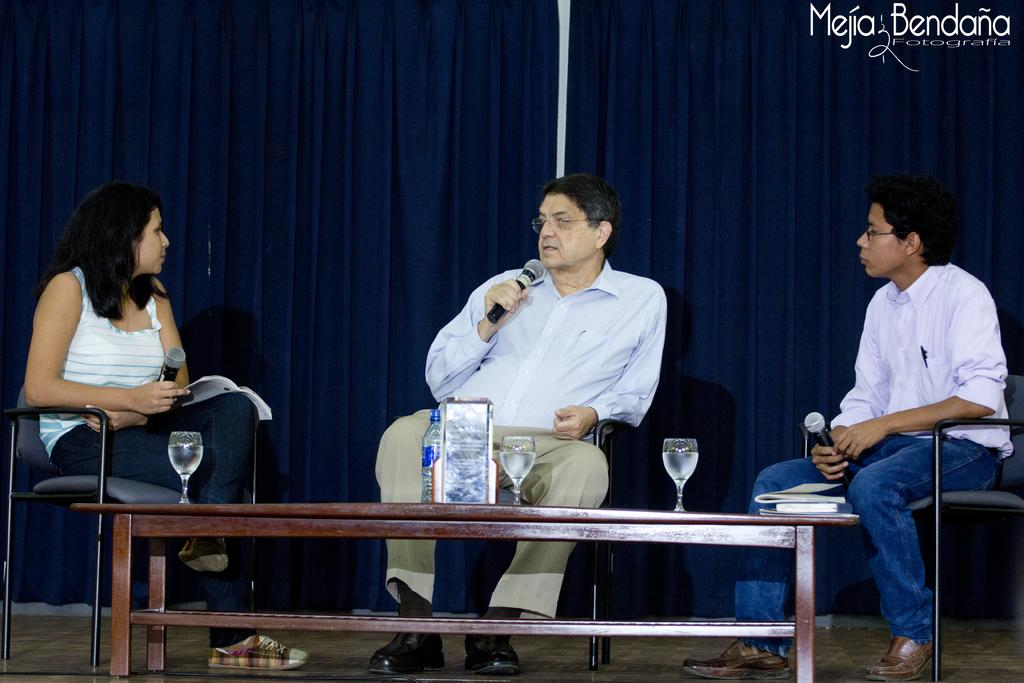What is hanging in the image? There is a curtain in the image. How many people are sitting in the image? There are three people sitting on chairs in the image. What is present in the image besides the people and curtain? There is a table in the image. What can be found on the table in the image? There is a bottle and glasses on the table in the image. What type of action is the toad performing in the image? There is no toad present in the image, so it is not possible to answer that question. 